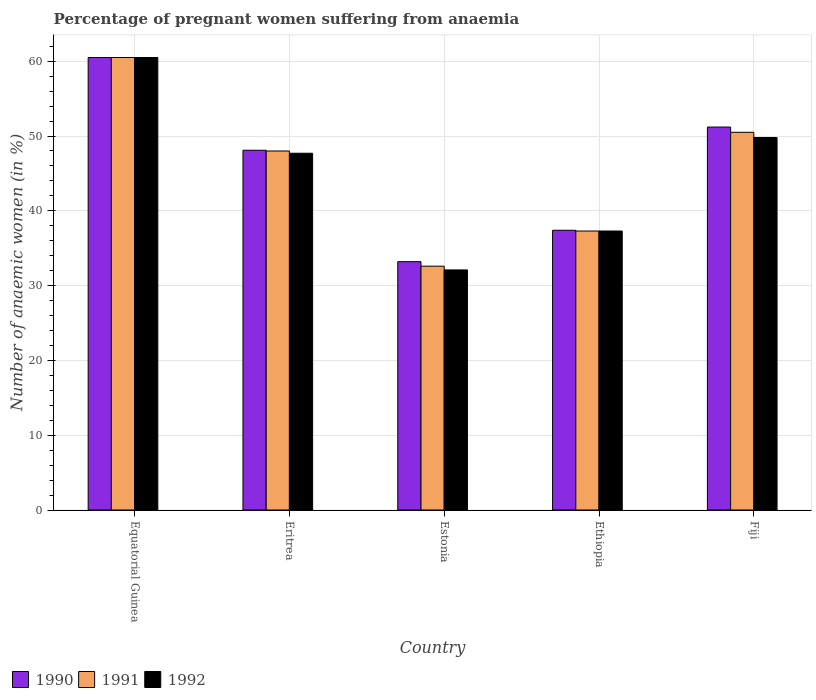How many different coloured bars are there?
Make the answer very short. 3. How many groups of bars are there?
Your answer should be very brief. 5. Are the number of bars per tick equal to the number of legend labels?
Your answer should be very brief. Yes. Are the number of bars on each tick of the X-axis equal?
Give a very brief answer. Yes. What is the label of the 4th group of bars from the left?
Provide a succinct answer. Ethiopia. In how many cases, is the number of bars for a given country not equal to the number of legend labels?
Provide a short and direct response. 0. What is the number of anaemic women in 1990 in Fiji?
Keep it short and to the point. 51.2. Across all countries, what is the maximum number of anaemic women in 1991?
Offer a terse response. 60.5. Across all countries, what is the minimum number of anaemic women in 1991?
Provide a short and direct response. 32.6. In which country was the number of anaemic women in 1990 maximum?
Your response must be concise. Equatorial Guinea. In which country was the number of anaemic women in 1992 minimum?
Keep it short and to the point. Estonia. What is the total number of anaemic women in 1990 in the graph?
Ensure brevity in your answer.  230.4. What is the difference between the number of anaemic women in 1991 in Eritrea and that in Estonia?
Provide a succinct answer. 15.4. What is the difference between the number of anaemic women in 1992 in Eritrea and the number of anaemic women in 1991 in Fiji?
Keep it short and to the point. -2.8. What is the average number of anaemic women in 1992 per country?
Your answer should be compact. 45.48. What is the difference between the number of anaemic women of/in 1990 and number of anaemic women of/in 1991 in Equatorial Guinea?
Offer a very short reply. 0. What is the ratio of the number of anaemic women in 1991 in Equatorial Guinea to that in Estonia?
Your response must be concise. 1.86. Is the number of anaemic women in 1992 in Estonia less than that in Fiji?
Provide a succinct answer. Yes. Is the difference between the number of anaemic women in 1990 in Equatorial Guinea and Eritrea greater than the difference between the number of anaemic women in 1991 in Equatorial Guinea and Eritrea?
Provide a succinct answer. No. What is the difference between the highest and the second highest number of anaemic women in 1992?
Your response must be concise. -10.7. What is the difference between the highest and the lowest number of anaemic women in 1990?
Ensure brevity in your answer.  27.3. What does the 3rd bar from the right in Equatorial Guinea represents?
Provide a succinct answer. 1990. Are all the bars in the graph horizontal?
Provide a succinct answer. No. How many countries are there in the graph?
Your answer should be compact. 5. Are the values on the major ticks of Y-axis written in scientific E-notation?
Keep it short and to the point. No. Does the graph contain any zero values?
Provide a succinct answer. No. Does the graph contain grids?
Provide a succinct answer. Yes. What is the title of the graph?
Provide a succinct answer. Percentage of pregnant women suffering from anaemia. What is the label or title of the X-axis?
Make the answer very short. Country. What is the label or title of the Y-axis?
Your response must be concise. Number of anaemic women (in %). What is the Number of anaemic women (in %) of 1990 in Equatorial Guinea?
Ensure brevity in your answer.  60.5. What is the Number of anaemic women (in %) in 1991 in Equatorial Guinea?
Make the answer very short. 60.5. What is the Number of anaemic women (in %) of 1992 in Equatorial Guinea?
Your response must be concise. 60.5. What is the Number of anaemic women (in %) in 1990 in Eritrea?
Provide a short and direct response. 48.1. What is the Number of anaemic women (in %) in 1991 in Eritrea?
Give a very brief answer. 48. What is the Number of anaemic women (in %) of 1992 in Eritrea?
Make the answer very short. 47.7. What is the Number of anaemic women (in %) of 1990 in Estonia?
Provide a short and direct response. 33.2. What is the Number of anaemic women (in %) in 1991 in Estonia?
Provide a succinct answer. 32.6. What is the Number of anaemic women (in %) in 1992 in Estonia?
Make the answer very short. 32.1. What is the Number of anaemic women (in %) in 1990 in Ethiopia?
Offer a very short reply. 37.4. What is the Number of anaemic women (in %) in 1991 in Ethiopia?
Provide a succinct answer. 37.3. What is the Number of anaemic women (in %) of 1992 in Ethiopia?
Provide a short and direct response. 37.3. What is the Number of anaemic women (in %) in 1990 in Fiji?
Offer a terse response. 51.2. What is the Number of anaemic women (in %) of 1991 in Fiji?
Your answer should be compact. 50.5. What is the Number of anaemic women (in %) of 1992 in Fiji?
Your answer should be compact. 49.8. Across all countries, what is the maximum Number of anaemic women (in %) of 1990?
Your answer should be compact. 60.5. Across all countries, what is the maximum Number of anaemic women (in %) of 1991?
Keep it short and to the point. 60.5. Across all countries, what is the maximum Number of anaemic women (in %) of 1992?
Your response must be concise. 60.5. Across all countries, what is the minimum Number of anaemic women (in %) of 1990?
Give a very brief answer. 33.2. Across all countries, what is the minimum Number of anaemic women (in %) of 1991?
Your answer should be compact. 32.6. Across all countries, what is the minimum Number of anaemic women (in %) of 1992?
Your answer should be compact. 32.1. What is the total Number of anaemic women (in %) in 1990 in the graph?
Provide a succinct answer. 230.4. What is the total Number of anaemic women (in %) in 1991 in the graph?
Provide a succinct answer. 228.9. What is the total Number of anaemic women (in %) in 1992 in the graph?
Make the answer very short. 227.4. What is the difference between the Number of anaemic women (in %) of 1991 in Equatorial Guinea and that in Eritrea?
Give a very brief answer. 12.5. What is the difference between the Number of anaemic women (in %) in 1992 in Equatorial Guinea and that in Eritrea?
Offer a terse response. 12.8. What is the difference between the Number of anaemic women (in %) in 1990 in Equatorial Guinea and that in Estonia?
Give a very brief answer. 27.3. What is the difference between the Number of anaemic women (in %) in 1991 in Equatorial Guinea and that in Estonia?
Provide a short and direct response. 27.9. What is the difference between the Number of anaemic women (in %) in 1992 in Equatorial Guinea and that in Estonia?
Offer a terse response. 28.4. What is the difference between the Number of anaemic women (in %) of 1990 in Equatorial Guinea and that in Ethiopia?
Offer a terse response. 23.1. What is the difference between the Number of anaemic women (in %) in 1991 in Equatorial Guinea and that in Ethiopia?
Provide a succinct answer. 23.2. What is the difference between the Number of anaemic women (in %) of 1992 in Equatorial Guinea and that in Ethiopia?
Provide a short and direct response. 23.2. What is the difference between the Number of anaemic women (in %) in 1991 in Equatorial Guinea and that in Fiji?
Ensure brevity in your answer.  10. What is the difference between the Number of anaemic women (in %) of 1992 in Equatorial Guinea and that in Fiji?
Provide a succinct answer. 10.7. What is the difference between the Number of anaemic women (in %) of 1991 in Eritrea and that in Estonia?
Offer a very short reply. 15.4. What is the difference between the Number of anaemic women (in %) in 1992 in Eritrea and that in Estonia?
Keep it short and to the point. 15.6. What is the difference between the Number of anaemic women (in %) in 1990 in Eritrea and that in Ethiopia?
Your response must be concise. 10.7. What is the difference between the Number of anaemic women (in %) in 1992 in Eritrea and that in Ethiopia?
Your answer should be very brief. 10.4. What is the difference between the Number of anaemic women (in %) of 1991 in Eritrea and that in Fiji?
Make the answer very short. -2.5. What is the difference between the Number of anaemic women (in %) of 1992 in Eritrea and that in Fiji?
Provide a short and direct response. -2.1. What is the difference between the Number of anaemic women (in %) of 1990 in Estonia and that in Ethiopia?
Offer a very short reply. -4.2. What is the difference between the Number of anaemic women (in %) of 1991 in Estonia and that in Ethiopia?
Offer a terse response. -4.7. What is the difference between the Number of anaemic women (in %) of 1992 in Estonia and that in Ethiopia?
Give a very brief answer. -5.2. What is the difference between the Number of anaemic women (in %) of 1990 in Estonia and that in Fiji?
Provide a short and direct response. -18. What is the difference between the Number of anaemic women (in %) of 1991 in Estonia and that in Fiji?
Provide a succinct answer. -17.9. What is the difference between the Number of anaemic women (in %) in 1992 in Estonia and that in Fiji?
Make the answer very short. -17.7. What is the difference between the Number of anaemic women (in %) in 1991 in Ethiopia and that in Fiji?
Your response must be concise. -13.2. What is the difference between the Number of anaemic women (in %) of 1990 in Equatorial Guinea and the Number of anaemic women (in %) of 1991 in Estonia?
Your answer should be very brief. 27.9. What is the difference between the Number of anaemic women (in %) in 1990 in Equatorial Guinea and the Number of anaemic women (in %) in 1992 in Estonia?
Ensure brevity in your answer.  28.4. What is the difference between the Number of anaemic women (in %) of 1991 in Equatorial Guinea and the Number of anaemic women (in %) of 1992 in Estonia?
Give a very brief answer. 28.4. What is the difference between the Number of anaemic women (in %) of 1990 in Equatorial Guinea and the Number of anaemic women (in %) of 1991 in Ethiopia?
Give a very brief answer. 23.2. What is the difference between the Number of anaemic women (in %) of 1990 in Equatorial Guinea and the Number of anaemic women (in %) of 1992 in Ethiopia?
Offer a very short reply. 23.2. What is the difference between the Number of anaemic women (in %) in 1991 in Equatorial Guinea and the Number of anaemic women (in %) in 1992 in Ethiopia?
Make the answer very short. 23.2. What is the difference between the Number of anaemic women (in %) of 1990 in Equatorial Guinea and the Number of anaemic women (in %) of 1991 in Fiji?
Offer a very short reply. 10. What is the difference between the Number of anaemic women (in %) in 1990 in Eritrea and the Number of anaemic women (in %) in 1991 in Estonia?
Your answer should be compact. 15.5. What is the difference between the Number of anaemic women (in %) in 1990 in Eritrea and the Number of anaemic women (in %) in 1992 in Estonia?
Your response must be concise. 16. What is the difference between the Number of anaemic women (in %) in 1991 in Eritrea and the Number of anaemic women (in %) in 1992 in Estonia?
Provide a succinct answer. 15.9. What is the difference between the Number of anaemic women (in %) of 1990 in Eritrea and the Number of anaemic women (in %) of 1992 in Ethiopia?
Your response must be concise. 10.8. What is the difference between the Number of anaemic women (in %) of 1991 in Estonia and the Number of anaemic women (in %) of 1992 in Ethiopia?
Your answer should be compact. -4.7. What is the difference between the Number of anaemic women (in %) of 1990 in Estonia and the Number of anaemic women (in %) of 1991 in Fiji?
Ensure brevity in your answer.  -17.3. What is the difference between the Number of anaemic women (in %) of 1990 in Estonia and the Number of anaemic women (in %) of 1992 in Fiji?
Give a very brief answer. -16.6. What is the difference between the Number of anaemic women (in %) of 1991 in Estonia and the Number of anaemic women (in %) of 1992 in Fiji?
Provide a succinct answer. -17.2. What is the difference between the Number of anaemic women (in %) of 1990 in Ethiopia and the Number of anaemic women (in %) of 1991 in Fiji?
Your response must be concise. -13.1. What is the difference between the Number of anaemic women (in %) of 1990 in Ethiopia and the Number of anaemic women (in %) of 1992 in Fiji?
Your answer should be compact. -12.4. What is the difference between the Number of anaemic women (in %) of 1991 in Ethiopia and the Number of anaemic women (in %) of 1992 in Fiji?
Offer a very short reply. -12.5. What is the average Number of anaemic women (in %) in 1990 per country?
Give a very brief answer. 46.08. What is the average Number of anaemic women (in %) in 1991 per country?
Offer a terse response. 45.78. What is the average Number of anaemic women (in %) in 1992 per country?
Your answer should be very brief. 45.48. What is the difference between the Number of anaemic women (in %) in 1991 and Number of anaemic women (in %) in 1992 in Equatorial Guinea?
Your answer should be very brief. 0. What is the difference between the Number of anaemic women (in %) of 1990 and Number of anaemic women (in %) of 1991 in Eritrea?
Provide a succinct answer. 0.1. What is the difference between the Number of anaemic women (in %) of 1990 and Number of anaemic women (in %) of 1992 in Estonia?
Offer a very short reply. 1.1. What is the difference between the Number of anaemic women (in %) in 1990 and Number of anaemic women (in %) in 1992 in Ethiopia?
Ensure brevity in your answer.  0.1. What is the difference between the Number of anaemic women (in %) of 1991 and Number of anaemic women (in %) of 1992 in Ethiopia?
Make the answer very short. 0. What is the difference between the Number of anaemic women (in %) of 1990 and Number of anaemic women (in %) of 1991 in Fiji?
Offer a very short reply. 0.7. What is the difference between the Number of anaemic women (in %) in 1990 and Number of anaemic women (in %) in 1992 in Fiji?
Offer a terse response. 1.4. What is the difference between the Number of anaemic women (in %) in 1991 and Number of anaemic women (in %) in 1992 in Fiji?
Offer a very short reply. 0.7. What is the ratio of the Number of anaemic women (in %) of 1990 in Equatorial Guinea to that in Eritrea?
Offer a terse response. 1.26. What is the ratio of the Number of anaemic women (in %) of 1991 in Equatorial Guinea to that in Eritrea?
Keep it short and to the point. 1.26. What is the ratio of the Number of anaemic women (in %) of 1992 in Equatorial Guinea to that in Eritrea?
Your answer should be compact. 1.27. What is the ratio of the Number of anaemic women (in %) of 1990 in Equatorial Guinea to that in Estonia?
Offer a terse response. 1.82. What is the ratio of the Number of anaemic women (in %) of 1991 in Equatorial Guinea to that in Estonia?
Provide a short and direct response. 1.86. What is the ratio of the Number of anaemic women (in %) of 1992 in Equatorial Guinea to that in Estonia?
Provide a short and direct response. 1.88. What is the ratio of the Number of anaemic women (in %) of 1990 in Equatorial Guinea to that in Ethiopia?
Your answer should be compact. 1.62. What is the ratio of the Number of anaemic women (in %) in 1991 in Equatorial Guinea to that in Ethiopia?
Offer a terse response. 1.62. What is the ratio of the Number of anaemic women (in %) in 1992 in Equatorial Guinea to that in Ethiopia?
Give a very brief answer. 1.62. What is the ratio of the Number of anaemic women (in %) in 1990 in Equatorial Guinea to that in Fiji?
Your answer should be compact. 1.18. What is the ratio of the Number of anaemic women (in %) of 1991 in Equatorial Guinea to that in Fiji?
Keep it short and to the point. 1.2. What is the ratio of the Number of anaemic women (in %) of 1992 in Equatorial Guinea to that in Fiji?
Ensure brevity in your answer.  1.21. What is the ratio of the Number of anaemic women (in %) of 1990 in Eritrea to that in Estonia?
Ensure brevity in your answer.  1.45. What is the ratio of the Number of anaemic women (in %) in 1991 in Eritrea to that in Estonia?
Keep it short and to the point. 1.47. What is the ratio of the Number of anaemic women (in %) in 1992 in Eritrea to that in Estonia?
Your response must be concise. 1.49. What is the ratio of the Number of anaemic women (in %) in 1990 in Eritrea to that in Ethiopia?
Keep it short and to the point. 1.29. What is the ratio of the Number of anaemic women (in %) of 1991 in Eritrea to that in Ethiopia?
Keep it short and to the point. 1.29. What is the ratio of the Number of anaemic women (in %) in 1992 in Eritrea to that in Ethiopia?
Provide a succinct answer. 1.28. What is the ratio of the Number of anaemic women (in %) in 1990 in Eritrea to that in Fiji?
Your answer should be very brief. 0.94. What is the ratio of the Number of anaemic women (in %) of 1991 in Eritrea to that in Fiji?
Ensure brevity in your answer.  0.95. What is the ratio of the Number of anaemic women (in %) of 1992 in Eritrea to that in Fiji?
Your answer should be very brief. 0.96. What is the ratio of the Number of anaemic women (in %) of 1990 in Estonia to that in Ethiopia?
Give a very brief answer. 0.89. What is the ratio of the Number of anaemic women (in %) in 1991 in Estonia to that in Ethiopia?
Offer a terse response. 0.87. What is the ratio of the Number of anaemic women (in %) of 1992 in Estonia to that in Ethiopia?
Offer a very short reply. 0.86. What is the ratio of the Number of anaemic women (in %) of 1990 in Estonia to that in Fiji?
Your response must be concise. 0.65. What is the ratio of the Number of anaemic women (in %) of 1991 in Estonia to that in Fiji?
Offer a very short reply. 0.65. What is the ratio of the Number of anaemic women (in %) in 1992 in Estonia to that in Fiji?
Your answer should be compact. 0.64. What is the ratio of the Number of anaemic women (in %) in 1990 in Ethiopia to that in Fiji?
Ensure brevity in your answer.  0.73. What is the ratio of the Number of anaemic women (in %) in 1991 in Ethiopia to that in Fiji?
Offer a very short reply. 0.74. What is the ratio of the Number of anaemic women (in %) of 1992 in Ethiopia to that in Fiji?
Offer a very short reply. 0.75. What is the difference between the highest and the second highest Number of anaemic women (in %) in 1992?
Your response must be concise. 10.7. What is the difference between the highest and the lowest Number of anaemic women (in %) in 1990?
Your answer should be compact. 27.3. What is the difference between the highest and the lowest Number of anaemic women (in %) of 1991?
Your response must be concise. 27.9. What is the difference between the highest and the lowest Number of anaemic women (in %) in 1992?
Offer a terse response. 28.4. 